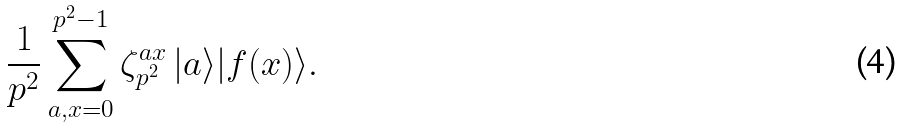Convert formula to latex. <formula><loc_0><loc_0><loc_500><loc_500>\frac { 1 } { p ^ { 2 } } \sum _ { a , x = 0 } ^ { p ^ { 2 } - 1 } \zeta _ { p ^ { 2 } } ^ { a x } \, | a \rangle | f ( x ) \rangle .</formula> 